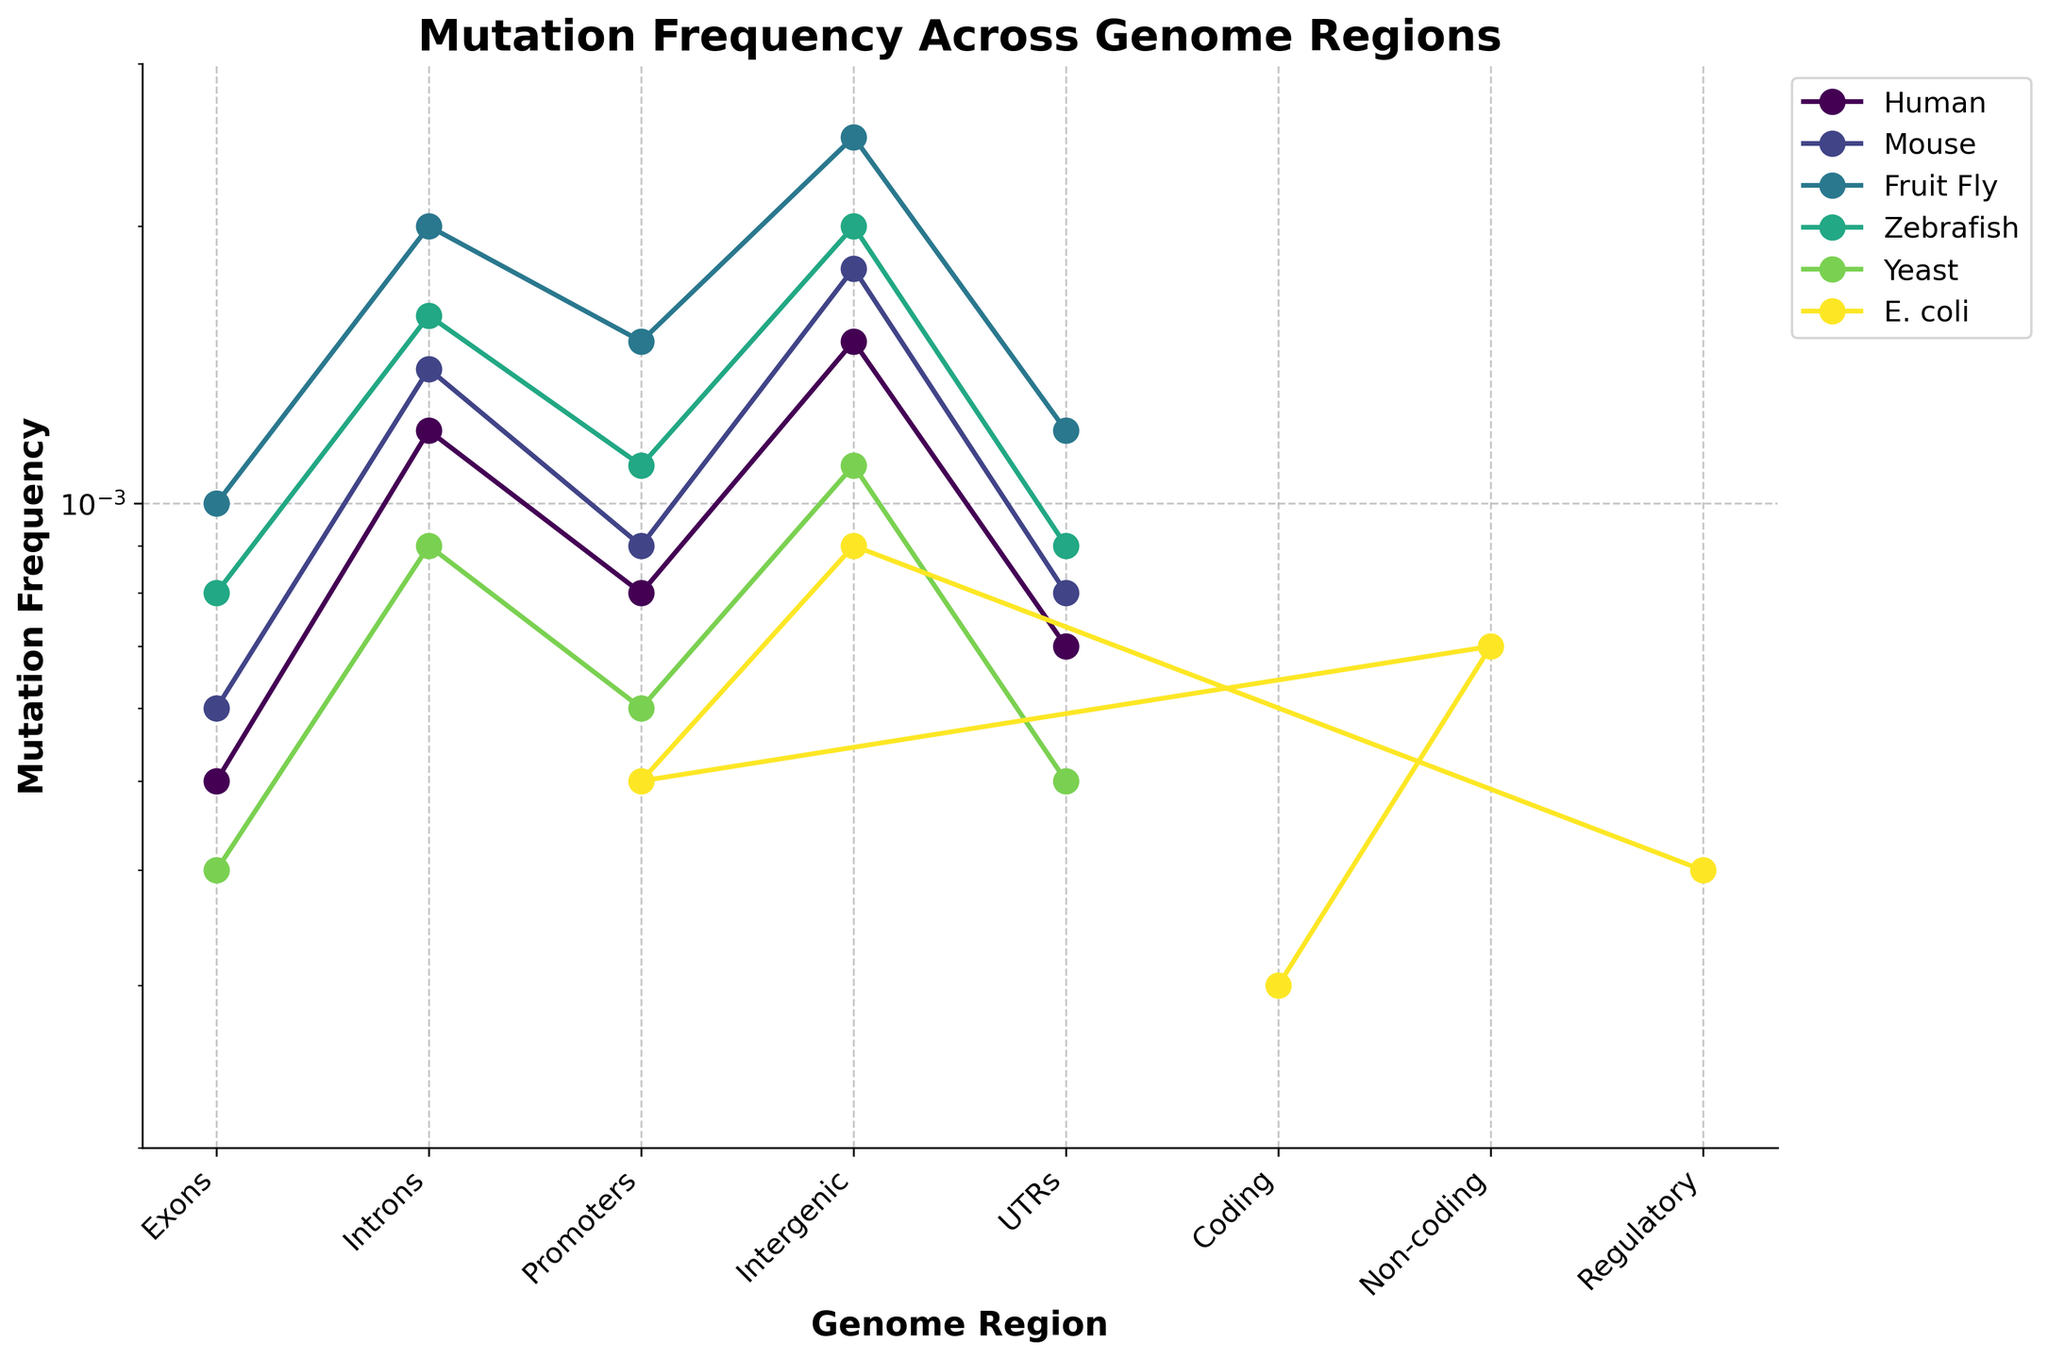Which species has the highest mutation frequency in the Intergenic region? First, identify the mutation frequency for the Intergenic region for each species. Among Human (0.0015), Mouse (0.0018), Fruit Fly (0.0025), Zebrafish (0.0020), Yeast (0.0011), and E. coli (0.0009), Fruit Fly has the highest frequency.
Answer: Fruit Fly Which genome region shows the lowest mutation frequency for E. coli? Identify the mutation frequencies for E. coli across different regions: Coding (0.0003), Non-coding (0.0007), Promoters (0.0005), Intergenic (0.0009), and Regulatory (0.0004). The lowest frequency is in the Coding region.
Answer: Coding What is the difference in mutation frequency in Introns between Mouse and Zebrafish? The mutation frequency in Introns for Mouse is 0.0014 and for Zebrafish is 0.0016. The difference is 0.0016 - 0.0014.
Answer: 0.0002 Which species shows the highest overall mutation frequency in any genome region? Check the mutation frequencies across all regions and species. The highest value across the board is for the Intergenic region of Fruit Fly (0.0025).
Answer: Fruit Fly What is the median mutation frequency for genome regions in Human? The mutation frequencies for Human are: Exons (0.0005), Introns (0.0012), Promoters (0.0008), Intergenic (0.0015), and UTRs (0.0007). The median is the middle value when sorted: 0.0005, 0.0007, 0.0008, 0.0012, 0.0015. The median is 0.0008.
Answer: 0.0008 Between Mouse and Yeast, which species shows greater variation in mutation frequencies across genome regions? Compare the mutation frequencies for Mouse: Exons (0.0006), Introns (0.0014), Promoters (0.0009), Intergenic (0.0018), and UTRs (0.0008); and Yeast: Exons (0.0004), Introns (0.0009), Promoters (0.0006), Intergenic (0.0011), and UTRs (0.0005). Compute the ranges: Mouse (0.0018 - 0.0006) = 0.0012, Yeast (0.0011 - 0.0004) = 0.0007. Mouse has greater variation.
Answer: Mouse Which genome region has the least variation in mutation frequency across all species? Find the minimum and maximum mutation frequencies for each genome region: Exons (0.0004 - 0.0010), Introns (0.0009 - 0.0020), Promoters (0.0005 - 0.0015), Intergenic (0.0009 - 0.0025), UTRs (0.0005 - 0.0012), Coding (0.0003), Non-coding (0.0007), Regulatory (0.0004). The Coding, Non-coding, and Regulatory regions vary the least as they only appear once. For common regions, Exons vary the least (0.0004 - 0.0010 = 0.0006).
Answer: Exons 